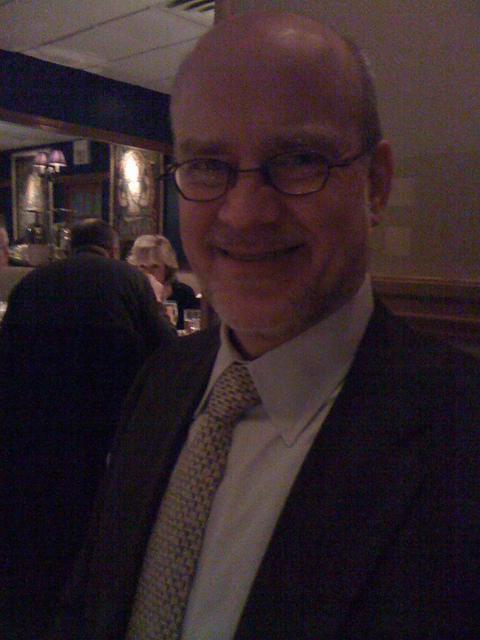What venue is the man in?
Make your selection from the four choices given to correctly answer the question.
Options: Home, restaurant, bathroom, hotel lobby. Restaurant. 